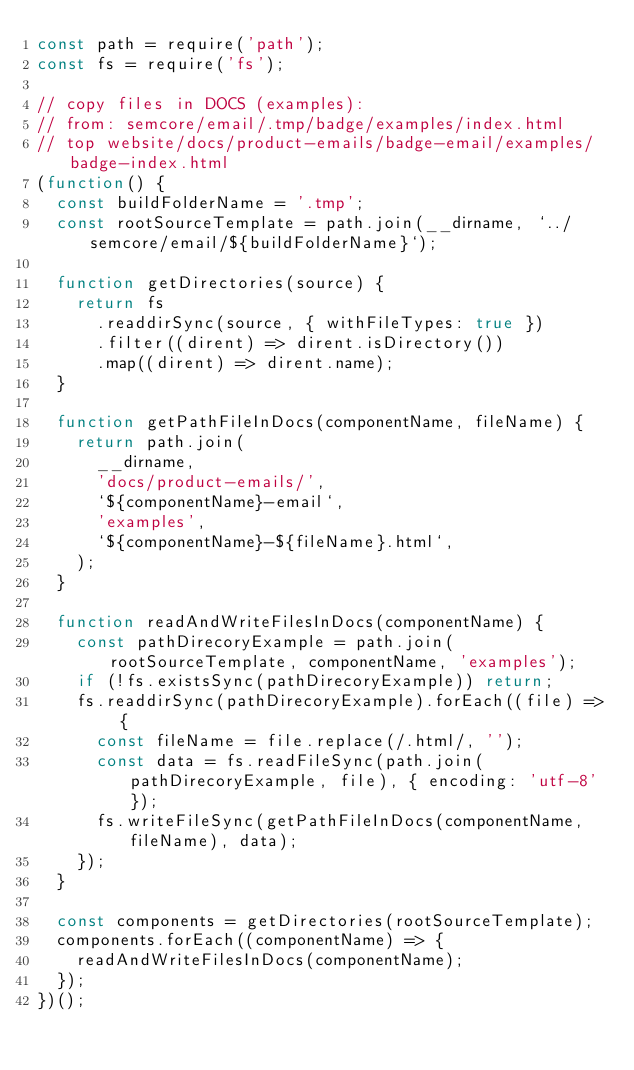Convert code to text. <code><loc_0><loc_0><loc_500><loc_500><_JavaScript_>const path = require('path');
const fs = require('fs');

// copy files in DOCS (examples):
// from: semcore/email/.tmp/badge/examples/index.html
// top website/docs/product-emails/badge-email/examples/badge-index.html
(function() {
  const buildFolderName = '.tmp';
  const rootSourceTemplate = path.join(__dirname, `../semcore/email/${buildFolderName}`);

  function getDirectories(source) {
    return fs
      .readdirSync(source, { withFileTypes: true })
      .filter((dirent) => dirent.isDirectory())
      .map((dirent) => dirent.name);
  }

  function getPathFileInDocs(componentName, fileName) {
    return path.join(
      __dirname,
      'docs/product-emails/',
      `${componentName}-email`,
      'examples',
      `${componentName}-${fileName}.html`,
    );
  }

  function readAndWriteFilesInDocs(componentName) {
    const pathDirecoryExample = path.join(rootSourceTemplate, componentName, 'examples');
    if (!fs.existsSync(pathDirecoryExample)) return;
    fs.readdirSync(pathDirecoryExample).forEach((file) => {
      const fileName = file.replace(/.html/, '');
      const data = fs.readFileSync(path.join(pathDirecoryExample, file), { encoding: 'utf-8' });
      fs.writeFileSync(getPathFileInDocs(componentName, fileName), data);
    });
  }

  const components = getDirectories(rootSourceTemplate);
  components.forEach((componentName) => {
    readAndWriteFilesInDocs(componentName);
  });
})();
</code> 